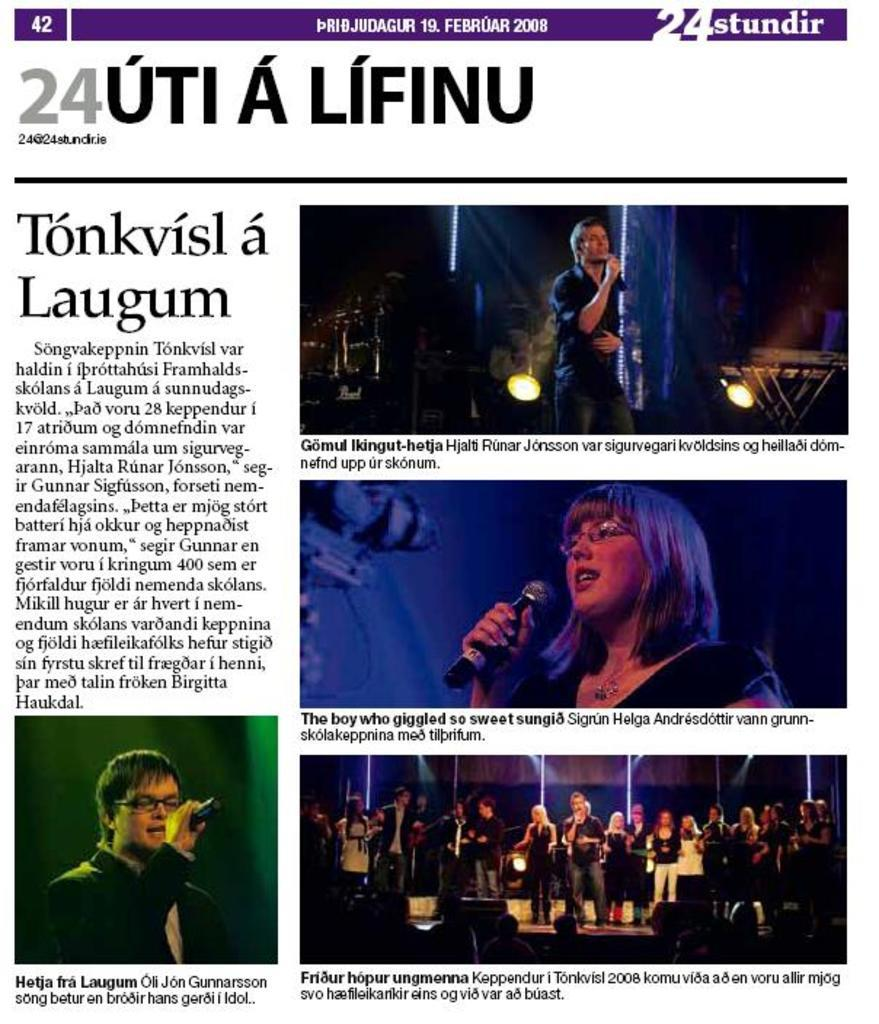What type of visual is the image? The image is a poster. What can be seen on the poster? There are pictures of people on the poster. What are the people in the pictures doing? The people in the pictures are holding microphones. What else is visible on the poster? There are focusing lights visible in the image. Is there any text on the poster? Yes, there is text written on the poster. How many ducks are swimming in the butter on the poster? There are no ducks or butter present on the poster; it features pictures of people holding microphones. 